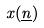Convert formula to latex. <formula><loc_0><loc_0><loc_500><loc_500>x ( \underline { n } )</formula> 